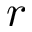Convert formula to latex. <formula><loc_0><loc_0><loc_500><loc_500>r</formula> 